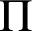<formula> <loc_0><loc_0><loc_500><loc_500>\Pi</formula> 